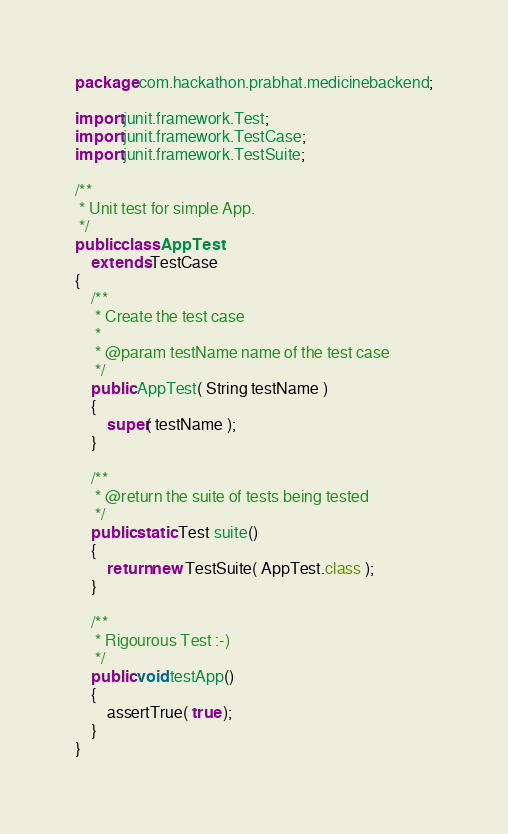Convert code to text. <code><loc_0><loc_0><loc_500><loc_500><_Java_>package com.hackathon.prabhat.medicinebackend;

import junit.framework.Test;
import junit.framework.TestCase;
import junit.framework.TestSuite;

/**
 * Unit test for simple App.
 */
public class AppTest 
    extends TestCase
{
    /**
     * Create the test case
     *
     * @param testName name of the test case
     */
    public AppTest( String testName )
    {
        super( testName );
    }

    /**
     * @return the suite of tests being tested
     */
    public static Test suite()
    {
        return new TestSuite( AppTest.class );
    }

    /**
     * Rigourous Test :-)
     */
    public void testApp()
    {
        assertTrue( true );
    }
}
</code> 